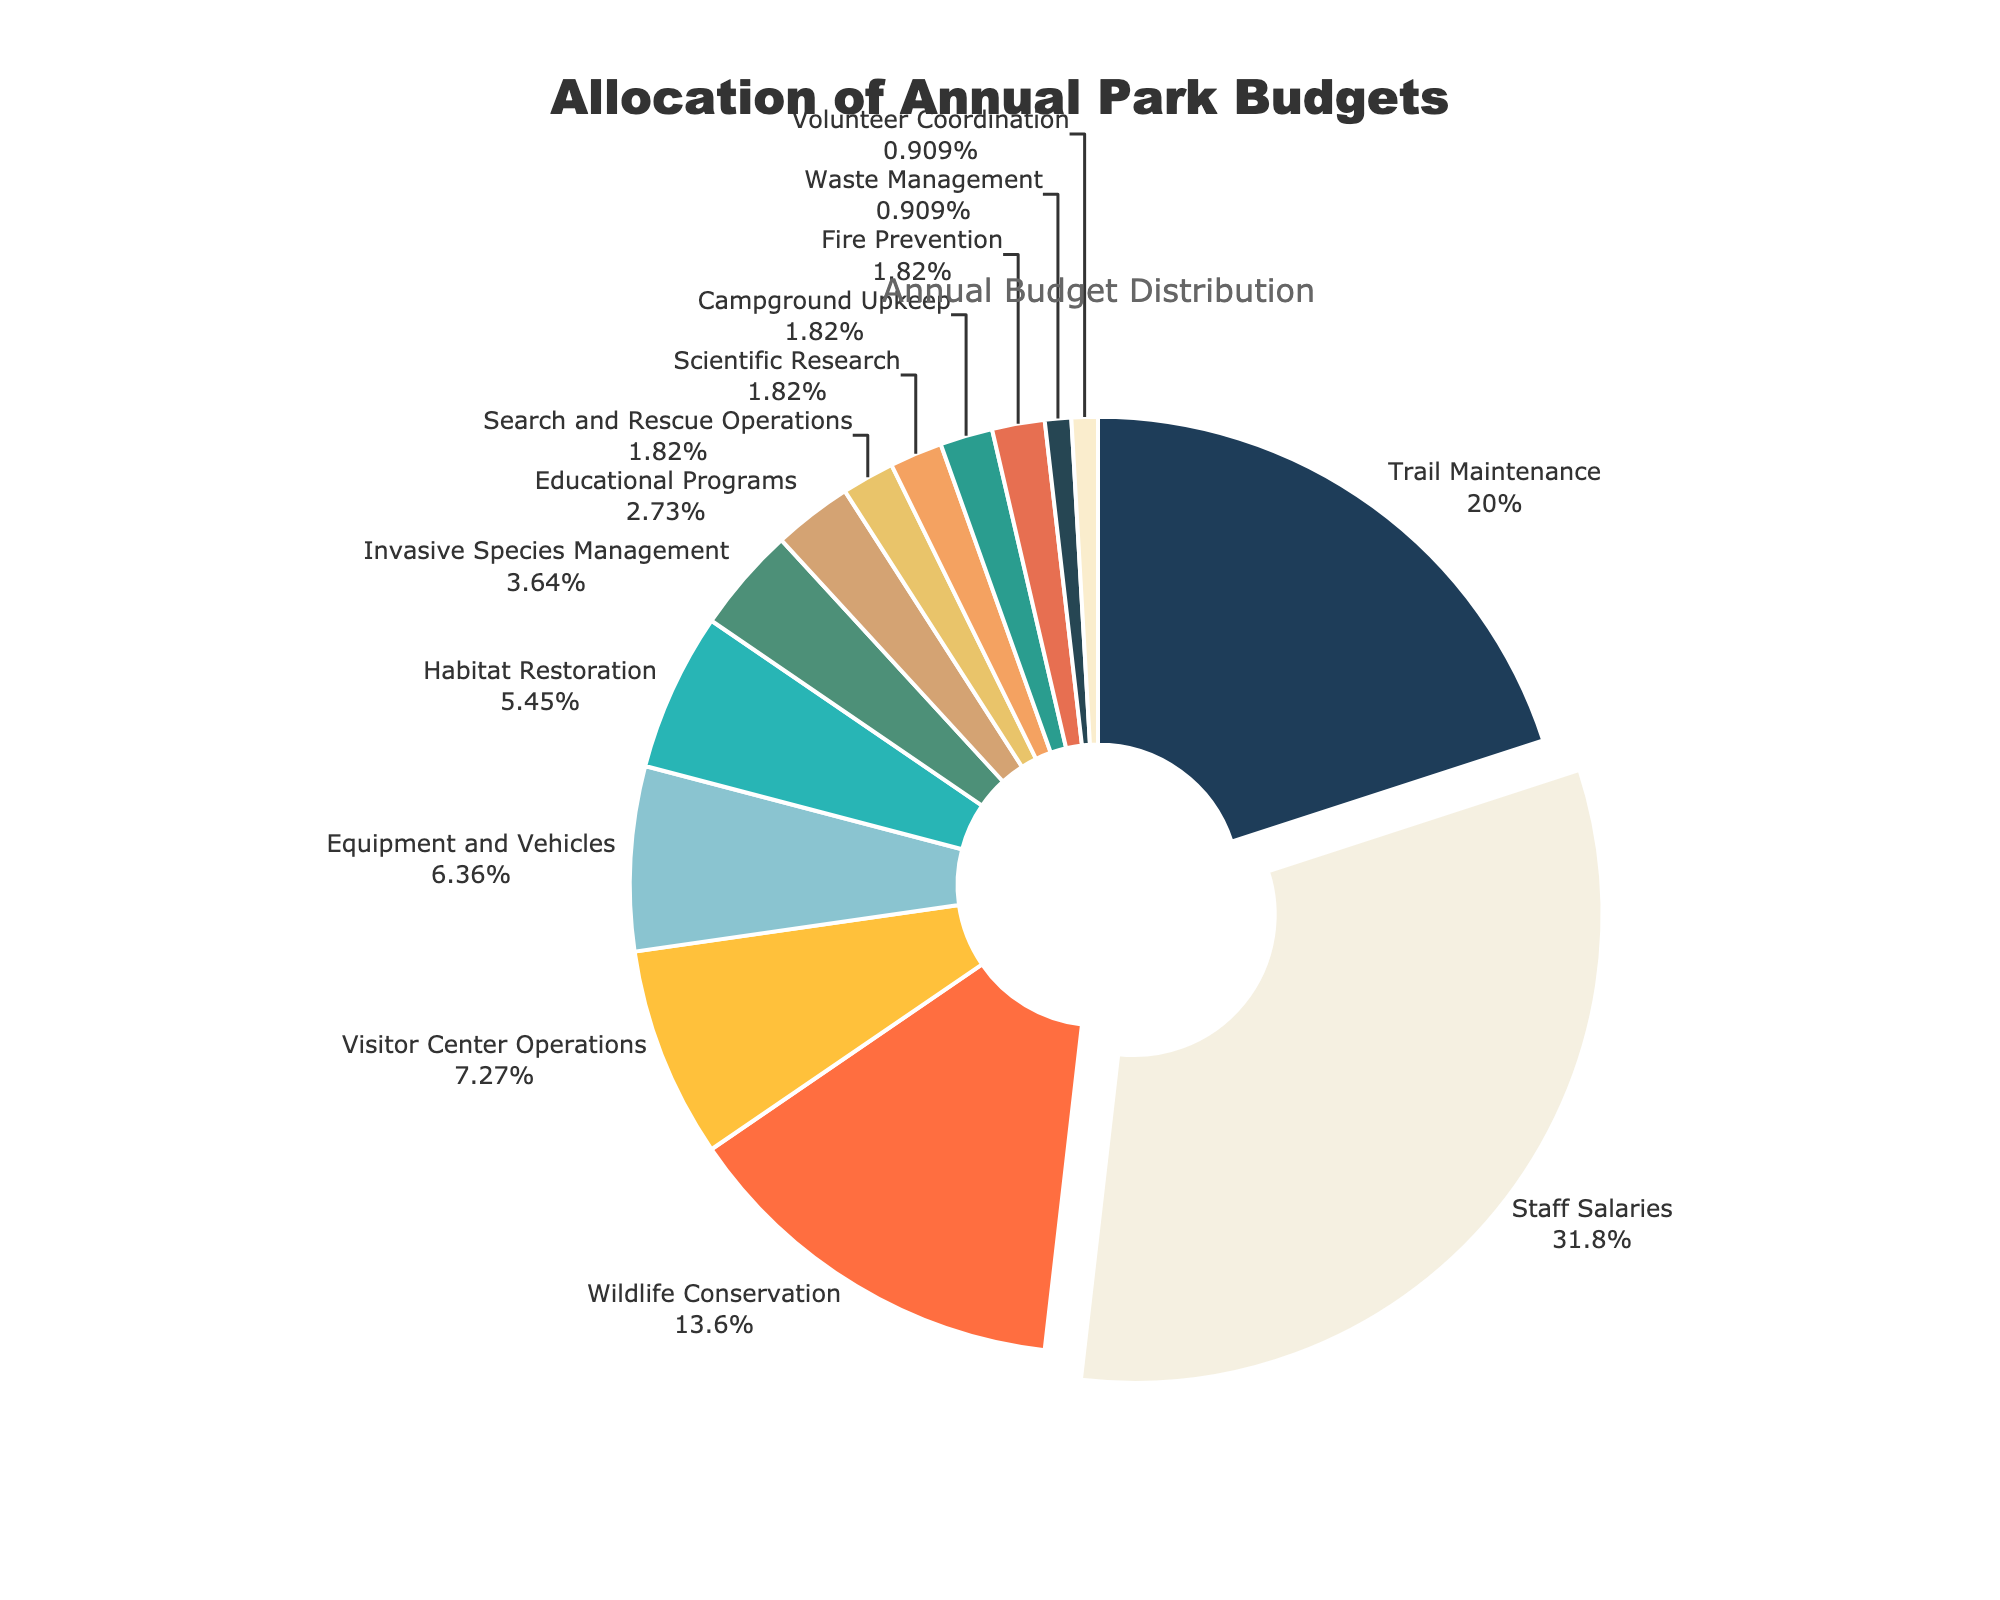Which category has the highest budget allocation? From the pie chart, the segment with the highest allocation percentage is visibly the largest. This is for Staff Salaries with a 35% share.
Answer: Staff Salaries How many categories have an allocation of 2%? Examining the chart, we see several segments annotated with a 2% allocation: Search and Rescue Operations, Scientific Research, Campground Upkeep, and Fire Prevention. There are 4 such categories.
Answer: 4 What is the combined budget allocation of Wildlife Conservation and Educational Programs? From the pie chart, Wildlife Conservation is 15% and Educational Programs is 3%. Adding these together gives 15% + 3% = 18%.
Answer: 18% Which areas have a lower allocation than Equipment and Vehicles? Equipment and Vehicles has an allocation of 7%. Comparing this to other segments, categories with lower allocations are Habitat Restoration (6%), Invasive Species Management (4%), Educational Programs (3%), Search and Rescue Operations (2%), Scientific Research (2%), Campground Upkeep (2%), Fire Prevention (2%), Waste Management (1%), and Volunteer Coordination (1%).
Answer: 9 categories What is the difference in budget allocation between Trail Maintenance and Habitat Restoration? From the pie chart, Trail Maintenance is 22% and Habitat Restoration is 6%. Subtracting the smaller from the larger gives 22% - 6% = 16%.
Answer: 16% Which category has the smallest slice in the pie chart? The smallest slice visually represents the category with the lowest allocation. Waste Management and Volunteer Coordination each have 1% allocation, sharing the smallest slice.
Answer: Waste Management and Volunteer Coordination What percentage of the budget is allocated to maintenance-related activities (Trail Maintenance, Equipment and Vehicles, Campground Upkeep)? The allocations are Trail Maintenance (22%), Equipment and Vehicles (7%), Campground Upkeep (2%). Adding these together gives 22% + 7% + 2% = 31%.
Answer: 31% Which categories occupy the same percentage of the budget? From the chart, both Search and Rescue Operations, Scientific Research, Campground Upkeep, and Fire Prevention each have an allocation of 2%.
Answer: Search and Rescue Operations, Scientific Research, Campground Upkeep, Fire Prevention 